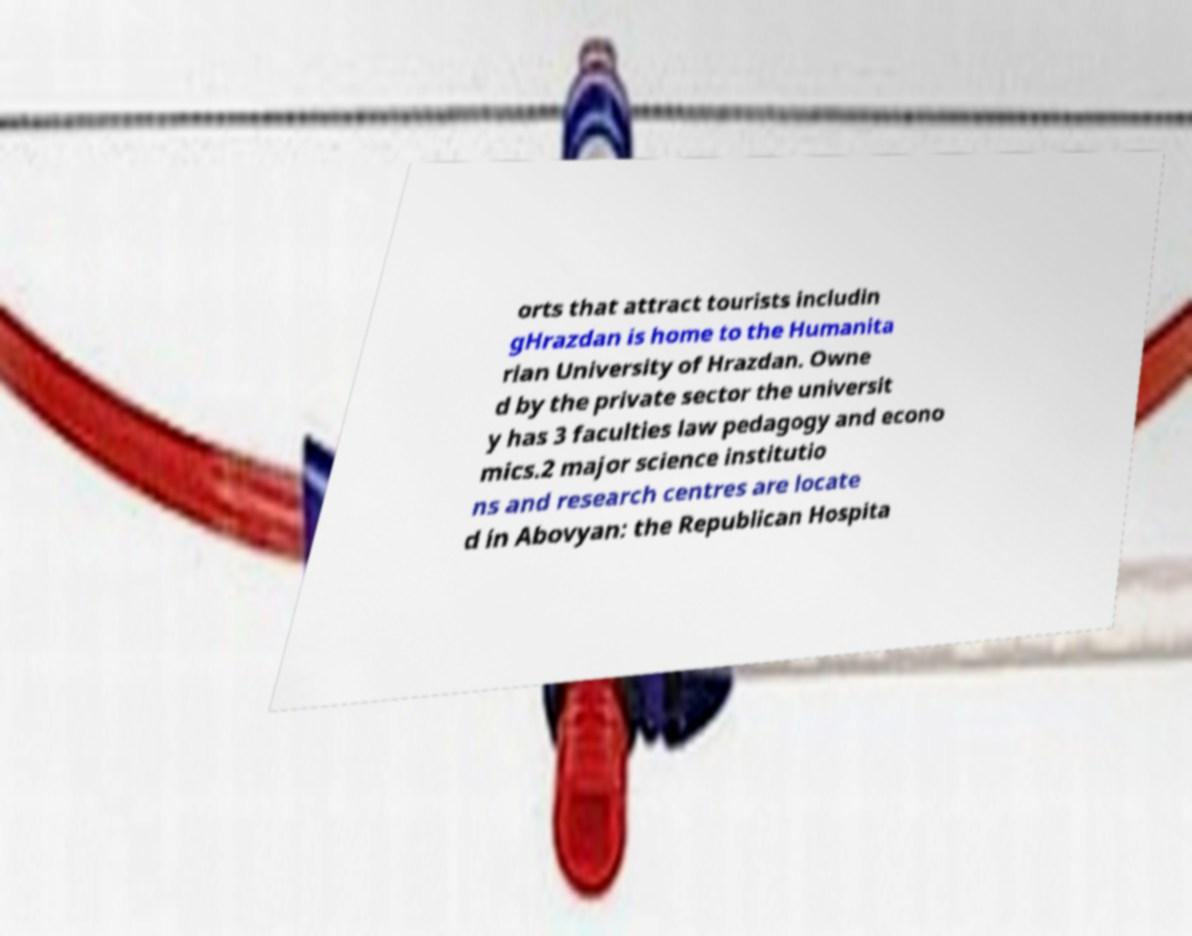There's text embedded in this image that I need extracted. Can you transcribe it verbatim? orts that attract tourists includin gHrazdan is home to the Humanita rian University of Hrazdan. Owne d by the private sector the universit y has 3 faculties law pedagogy and econo mics.2 major science institutio ns and research centres are locate d in Abovyan: the Republican Hospita 